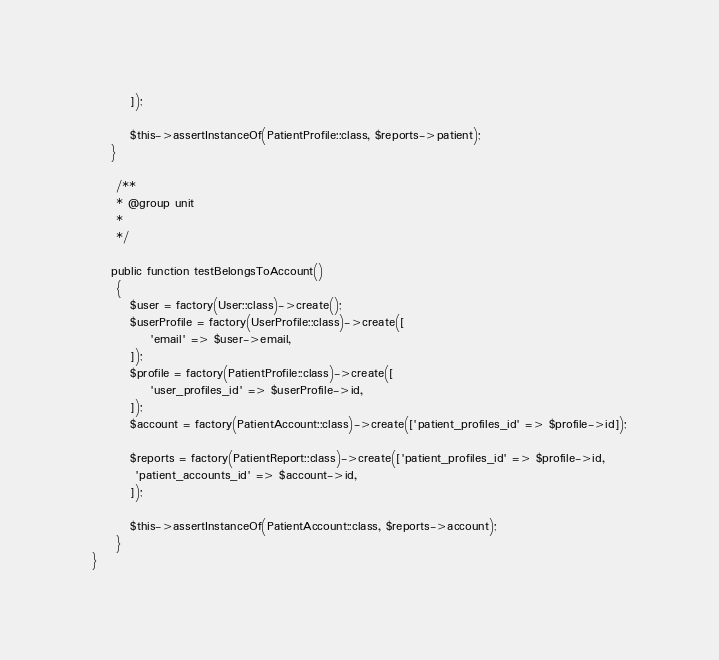<code> <loc_0><loc_0><loc_500><loc_500><_PHP_>        ]); 

        $this->assertInstanceOf(PatientProfile::class, $reports->patient);
    }

     /**
     * @group unit
     *
     */

    public function testBelongsToAccount()
     {
        $user = factory(User::class)->create();
        $userProfile = factory(UserProfile::class)->create([
            'email' => $user->email,
        ]);
        $profile = factory(PatientProfile::class)->create([
            'user_profiles_id' => $userProfile->id,
        ]);
        $account = factory(PatientAccount::class)->create(['patient_profiles_id' => $profile->id]);

        $reports = factory(PatientReport::class)->create(['patient_profiles_id' => $profile->id,
         'patient_accounts_id' => $account->id,
        ]); 

        $this->assertInstanceOf(PatientAccount::class, $reports->account);
     }
}
</code> 